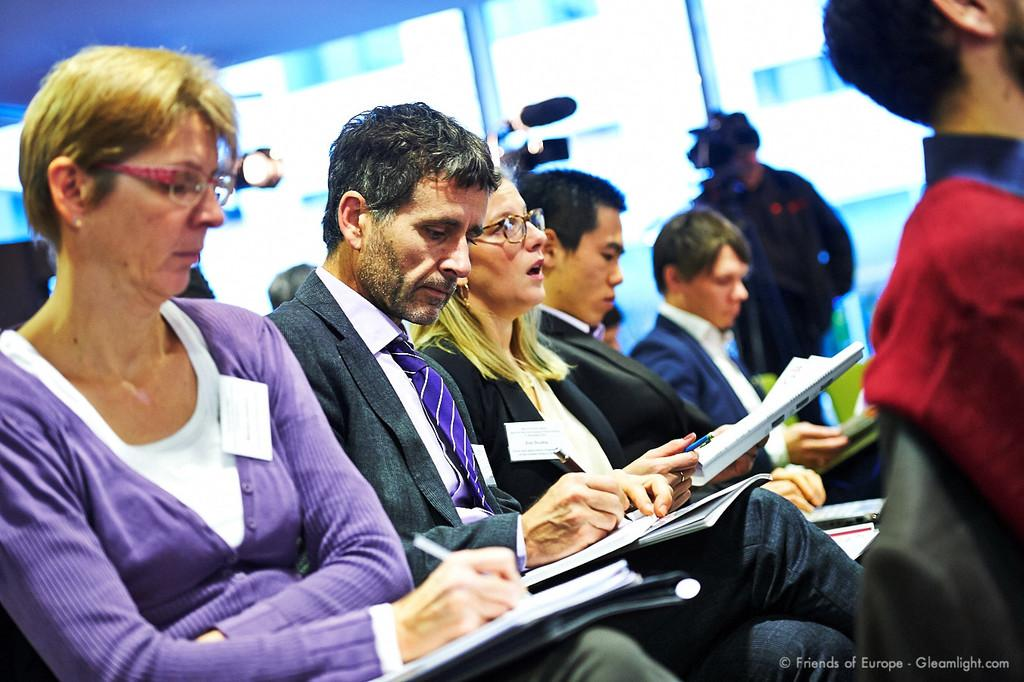What are the persons in the image holding? The persons in the image are holding papers and pens. What can be seen at the top of the image? There is a window visible at the top of the image. Who is positioned in front of the window? There is a camera man in front of the window. Reasoning: Let' Let's think step by step in order to produce the conversation. We start by identifying the main subjects in the image, which are the persons holding papers and pens. Then, we describe the window visible at the top of the image and the presence of a camera man in front of it. Each question is designed to elicit a specific detail about the image that is known from the provided facts. Absurd Question/Answer: What type of tin can be seen being pushed by the persons in the image? There is no tin present in the image, nor are the persons pushing anything. What type of tin can be seen being pushed by the persons in the image? There is no tin present in the image, nor are the persons pushing anything. 